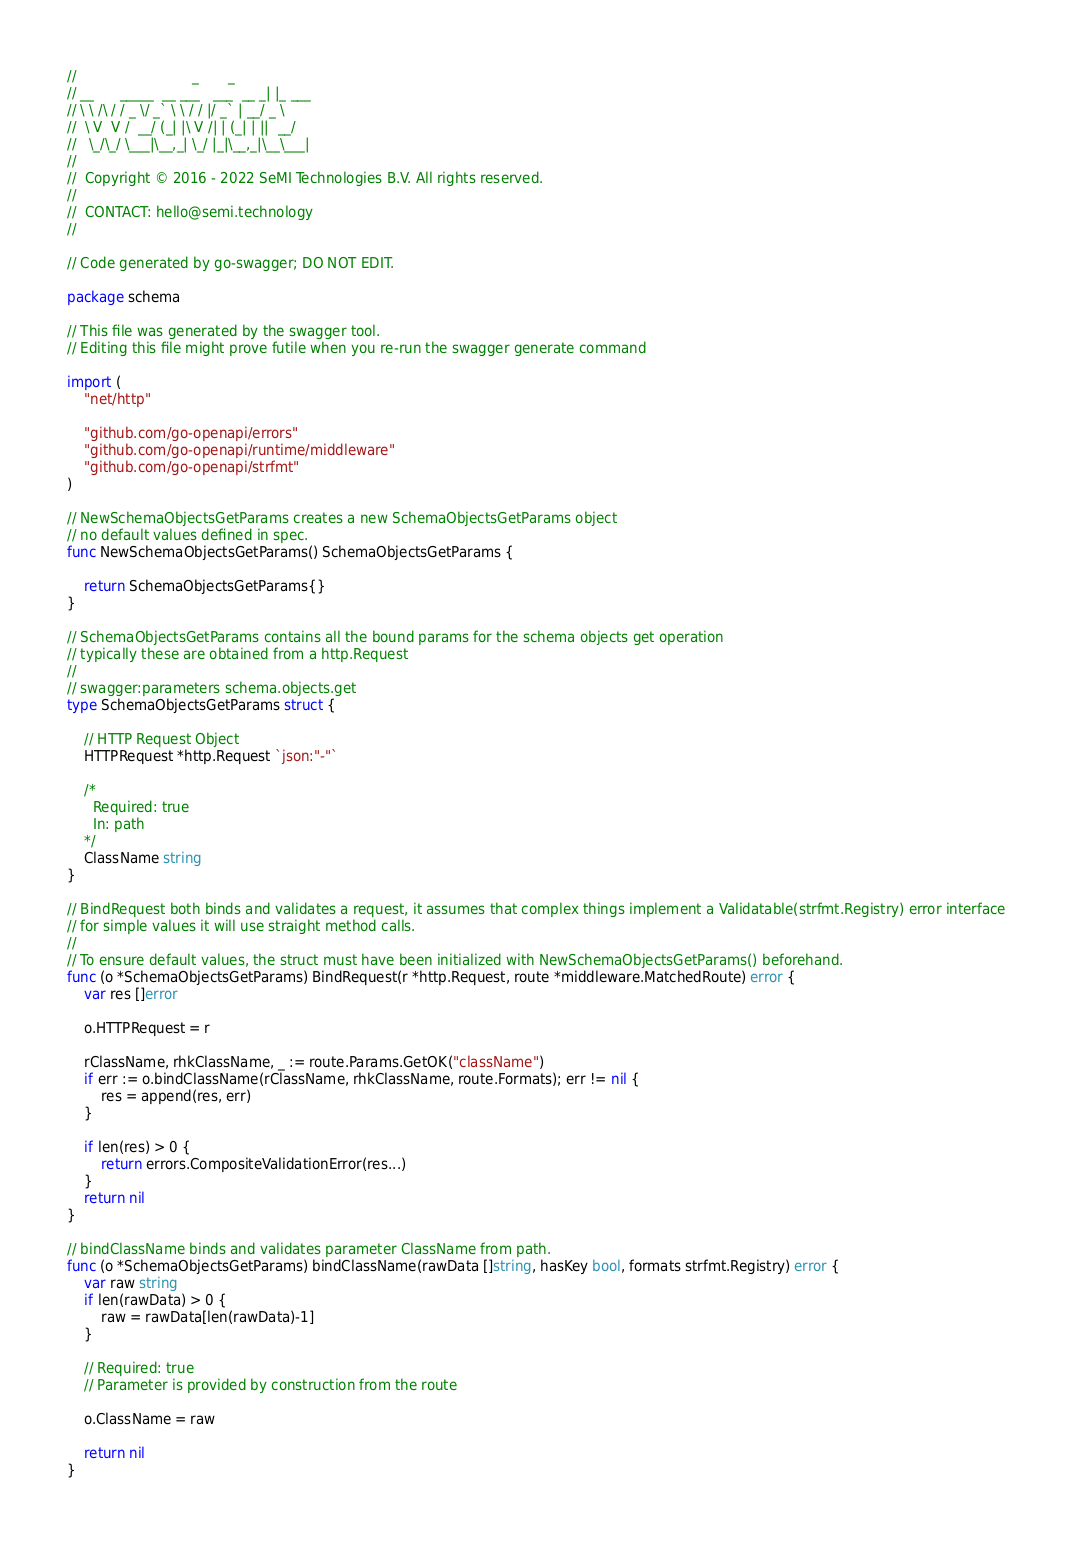Convert code to text. <code><loc_0><loc_0><loc_500><loc_500><_Go_>//                           _       _
// __      _____  __ ___   ___  __ _| |_ ___
// \ \ /\ / / _ \/ _` \ \ / / |/ _` | __/ _ \
//  \ V  V /  __/ (_| |\ V /| | (_| | ||  __/
//   \_/\_/ \___|\__,_| \_/ |_|\__,_|\__\___|
//
//  Copyright © 2016 - 2022 SeMI Technologies B.V. All rights reserved.
//
//  CONTACT: hello@semi.technology
//

// Code generated by go-swagger; DO NOT EDIT.

package schema

// This file was generated by the swagger tool.
// Editing this file might prove futile when you re-run the swagger generate command

import (
	"net/http"

	"github.com/go-openapi/errors"
	"github.com/go-openapi/runtime/middleware"
	"github.com/go-openapi/strfmt"
)

// NewSchemaObjectsGetParams creates a new SchemaObjectsGetParams object
// no default values defined in spec.
func NewSchemaObjectsGetParams() SchemaObjectsGetParams {

	return SchemaObjectsGetParams{}
}

// SchemaObjectsGetParams contains all the bound params for the schema objects get operation
// typically these are obtained from a http.Request
//
// swagger:parameters schema.objects.get
type SchemaObjectsGetParams struct {

	// HTTP Request Object
	HTTPRequest *http.Request `json:"-"`

	/*
	  Required: true
	  In: path
	*/
	ClassName string
}

// BindRequest both binds and validates a request, it assumes that complex things implement a Validatable(strfmt.Registry) error interface
// for simple values it will use straight method calls.
//
// To ensure default values, the struct must have been initialized with NewSchemaObjectsGetParams() beforehand.
func (o *SchemaObjectsGetParams) BindRequest(r *http.Request, route *middleware.MatchedRoute) error {
	var res []error

	o.HTTPRequest = r

	rClassName, rhkClassName, _ := route.Params.GetOK("className")
	if err := o.bindClassName(rClassName, rhkClassName, route.Formats); err != nil {
		res = append(res, err)
	}

	if len(res) > 0 {
		return errors.CompositeValidationError(res...)
	}
	return nil
}

// bindClassName binds and validates parameter ClassName from path.
func (o *SchemaObjectsGetParams) bindClassName(rawData []string, hasKey bool, formats strfmt.Registry) error {
	var raw string
	if len(rawData) > 0 {
		raw = rawData[len(rawData)-1]
	}

	// Required: true
	// Parameter is provided by construction from the route

	o.ClassName = raw

	return nil
}
</code> 